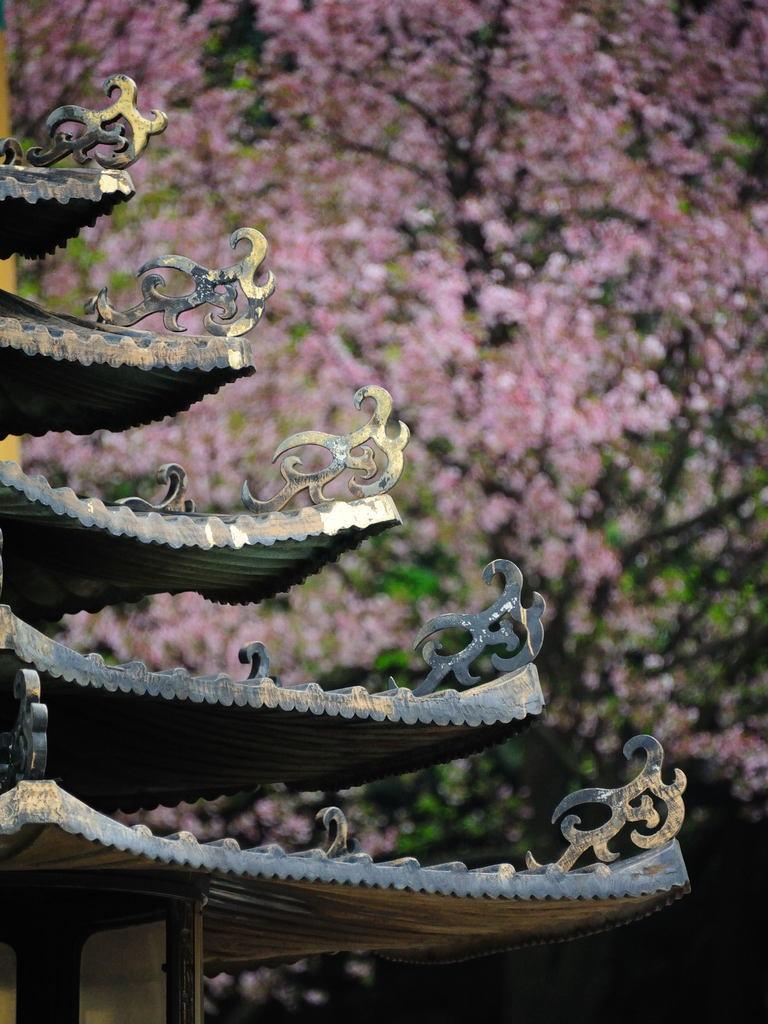How would you summarize this image in a sentence or two? In this image I can see the roof of a house along with some sculptures. In the background there are many trees. 